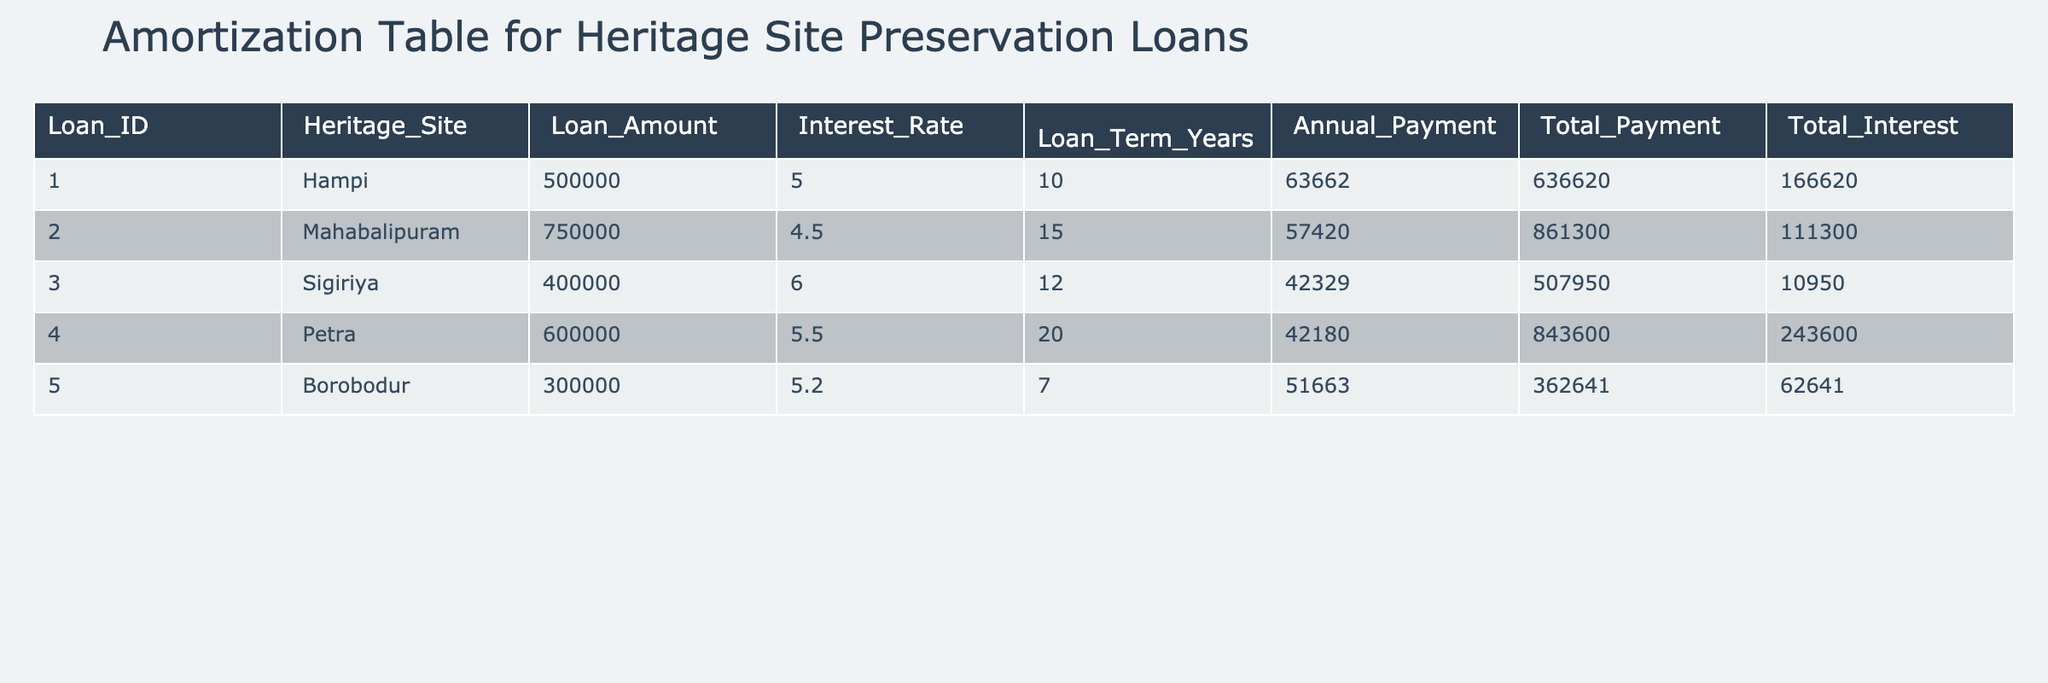What is the loan amount for the heritage site Hampi? Referring to the table, under the column "Loan_Amount" for the row corresponding to Hampi, the value is 500000.
Answer: 500000 What is the interest rate for the loan taken for the Borobodur heritage site? Looking at the table, the interest rate for Borobodur is found in the "Interest_Rate" column and is 5.2.
Answer: 5.2 Which heritage site has the lowest total interest payment? To find this, we compare the values in the "Total_Interest" column. The lowest value is 10950 for Sigiriya.
Answer: Sigiriya What is the average annual payment across all listed loans? We sum the annual payments from the "Annual_Payment" column, which are (63662 + 57420 + 42329 + 42180 + 51663). This equals 229254. Dividing by the number of loans (5) gives an average of 45850.8.
Answer: 45850.8 Is the total payment for the Mahabalipuram loan more than 800000? The total payment for Mahabalipuram is listed as 861300. Since 861300 is greater than 800000, the answer is yes.
Answer: Yes What is the difference in total payment between the loans for Hampi and Petra? The total payment for Hampi is 636620 and for Petra is 843600. The difference is calculated as 843600 - 636620 = 206980.
Answer: 206980 Which heritage site has the longest loan term, and what is that term? By scanning the "Loan_Term_Years" column, we find that Petra has the longest loan term of 20 years.
Answer: Petra, 20 years If you combine the loan amounts for Sigiriya and Borobodur, what is the total? The loan amount for Sigiriya is 400000 and for Borobodur is 300000. Adding these gives 400000 + 300000 = 700000.
Answer: 700000 Is it true that all heritage sites have an interest rate of at least 4.5%? Checking the "Interest_Rate" column shows that all interest rates are: 5.0, 4.5, 6.0, 5.5, and 5.2. Since the lowest is 4.5%, this statement is true.
Answer: Yes 